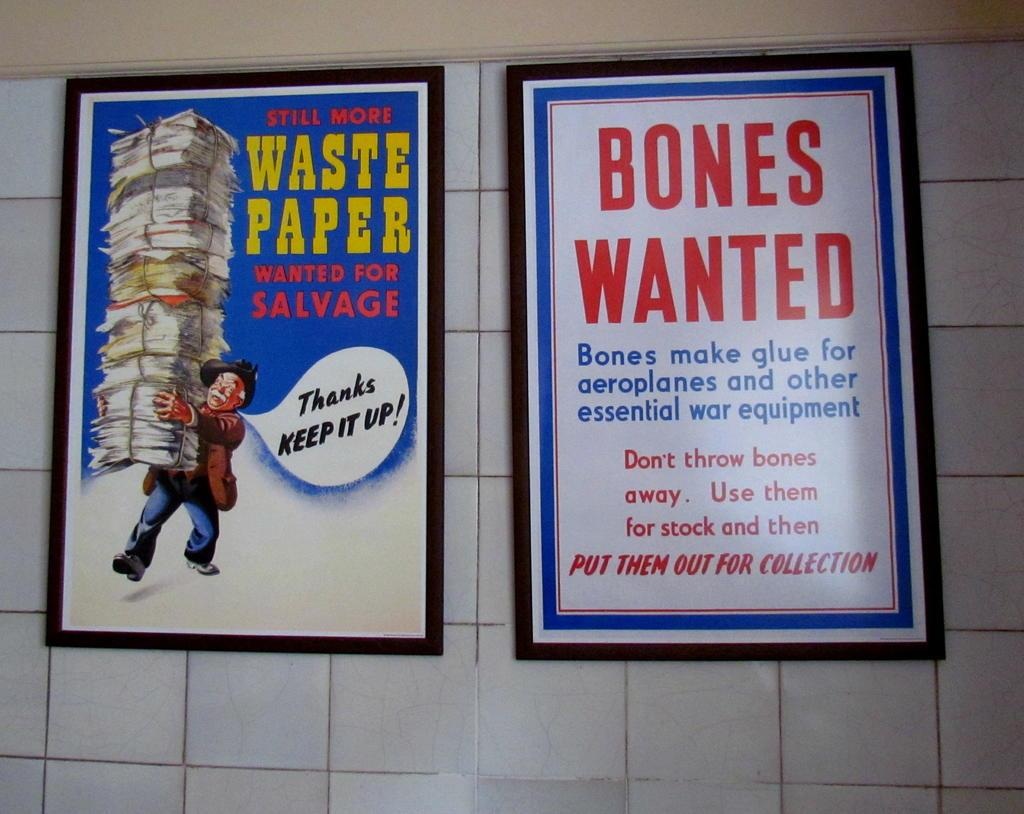<image>
Describe the image concisely. Two signs, one requesting waste paper and the other for bones wanted. 